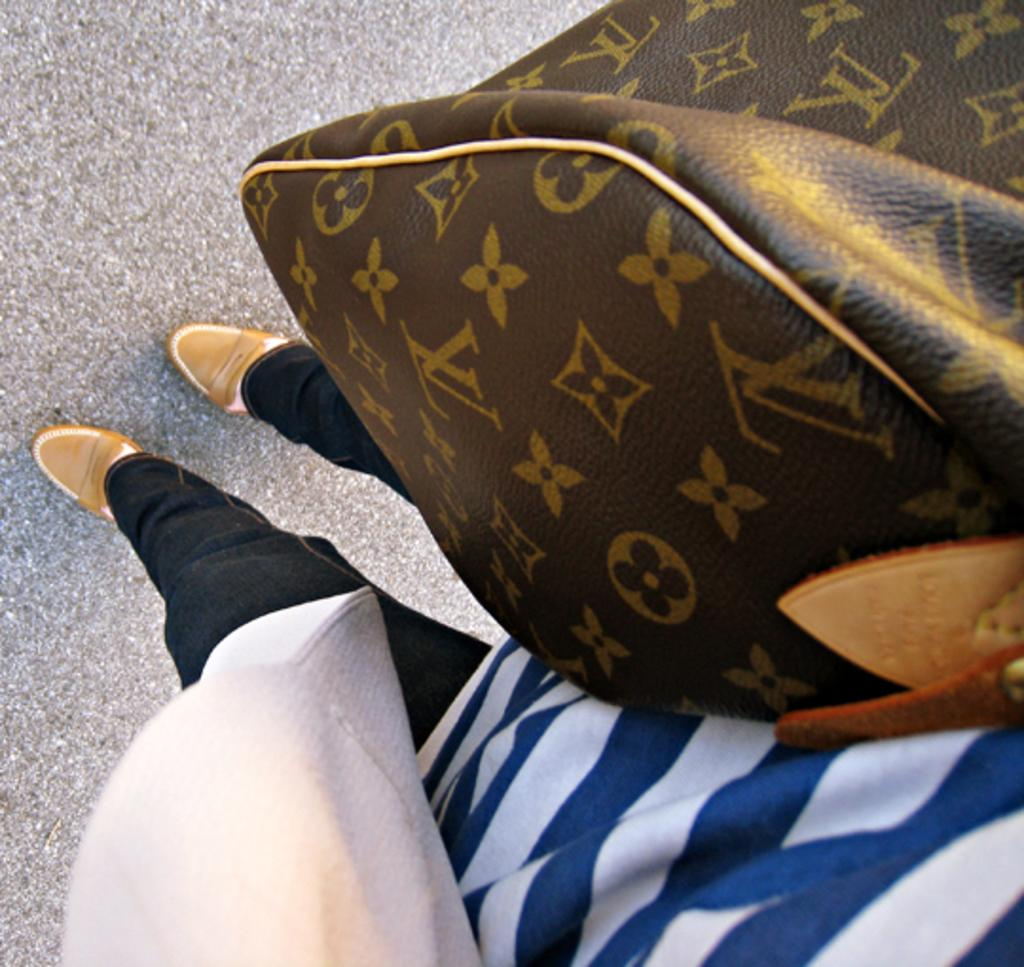What is the woman doing in the image? The woman is standing in the image. What is the woman holding in the image? The woman is holding a handbag on the right side. What color combination is the woman's t-shirt? The woman is wearing a blue and white color t-shirt. What color are the woman's trousers? The woman is wearing black color trousers. What color are the woman's shoes? The woman is wearing gold color shoes. What type of music is the woman listening to in the image? There is no indication in the image that the woman is listening to music. What kind of cheese is the woman holding in the image? There is no cheese present in the image. 